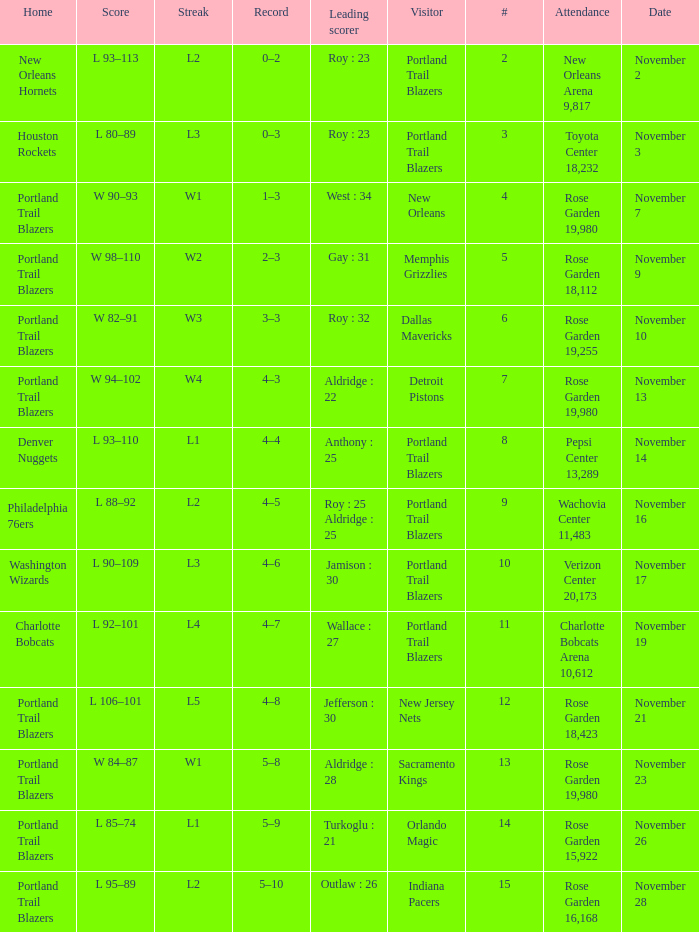 who is the leading scorer where home is charlotte bobcats Wallace : 27. 